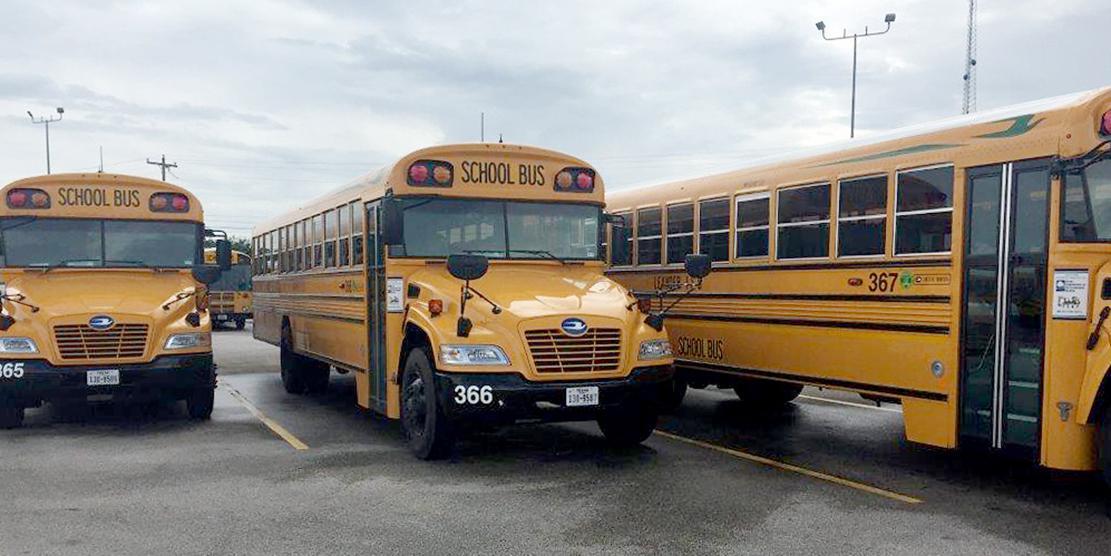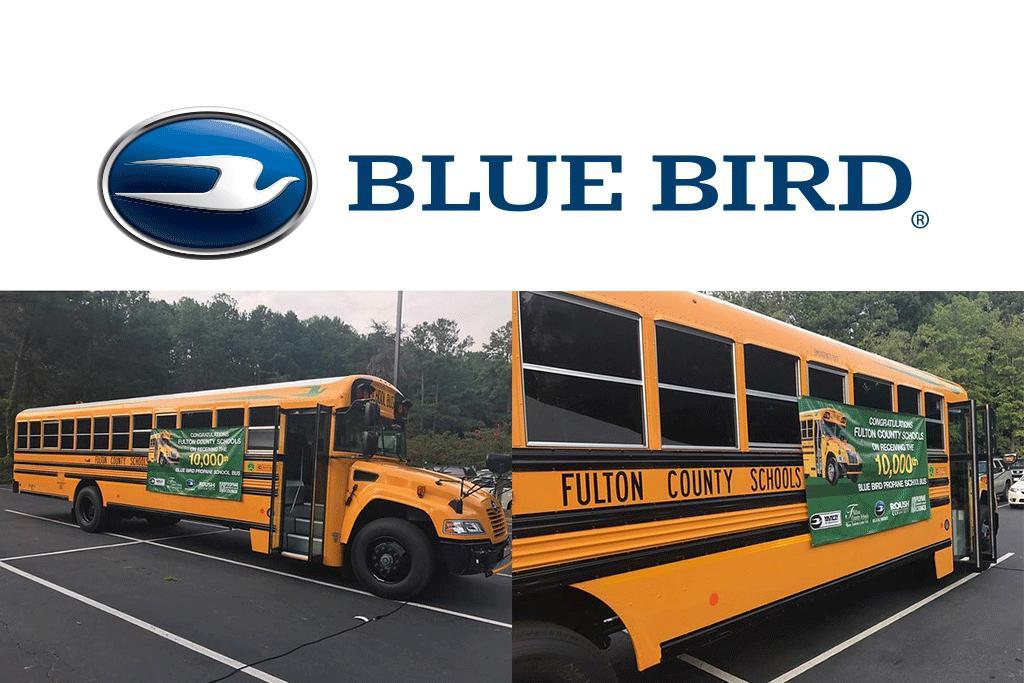The first image is the image on the left, the second image is the image on the right. Analyze the images presented: Is the assertion "The right image shows one flat-fronted bus displayed diagonally and forward-facing, and the left image includes at least one bus that has a non-flat front." valid? Answer yes or no. No. The first image is the image on the left, the second image is the image on the right. Considering the images on both sides, is "There are more buses in the image on the left." valid? Answer yes or no. Yes. 